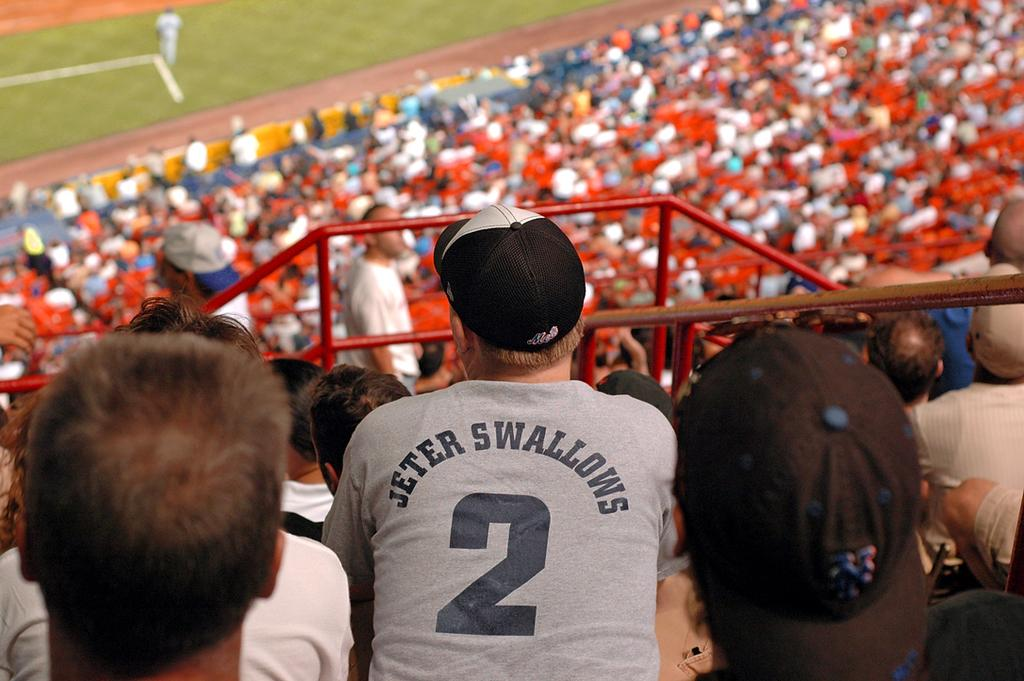<image>
Write a terse but informative summary of the picture. a man at a baseball game with Jeter Swallows 2 on the back of his shirt.. 